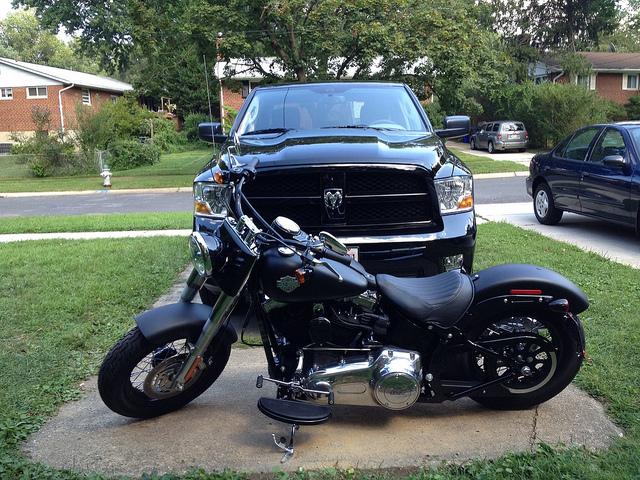What is the make of the truck?
Concise answer only. Dodge. What vehicle is in front of the car?
Quick response, please. Motorcycle. How many red motorcycles?
Concise answer only. 0. Where would a fire truck park if there were a fire?
Write a very short answer. Street. 